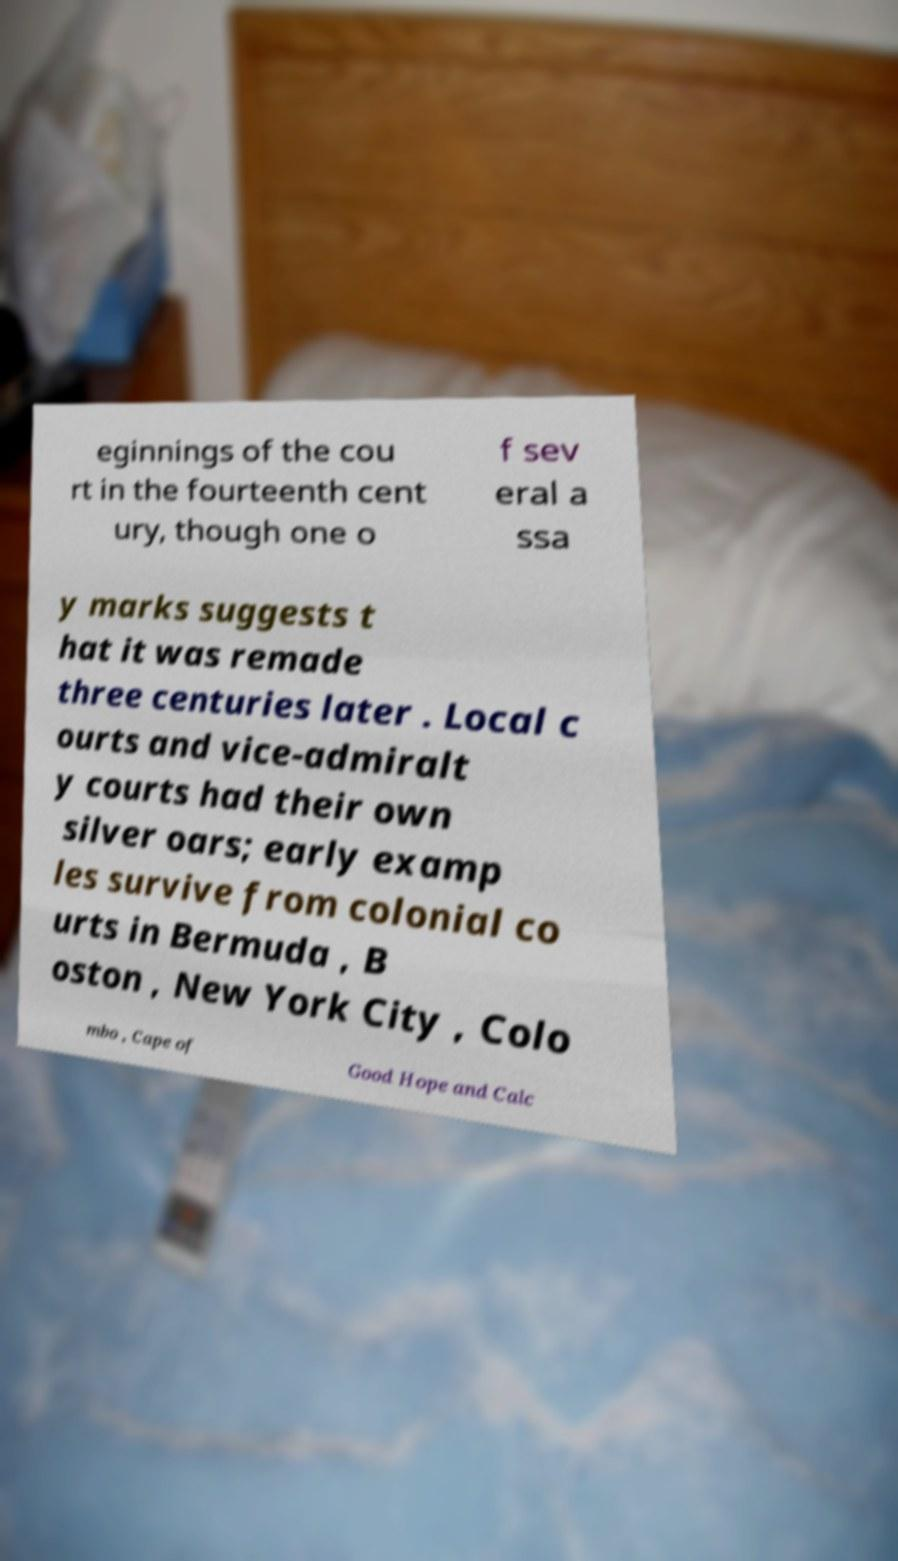For documentation purposes, I need the text within this image transcribed. Could you provide that? eginnings of the cou rt in the fourteenth cent ury, though one o f sev eral a ssa y marks suggests t hat it was remade three centuries later . Local c ourts and vice-admiralt y courts had their own silver oars; early examp les survive from colonial co urts in Bermuda , B oston , New York City , Colo mbo , Cape of Good Hope and Calc 